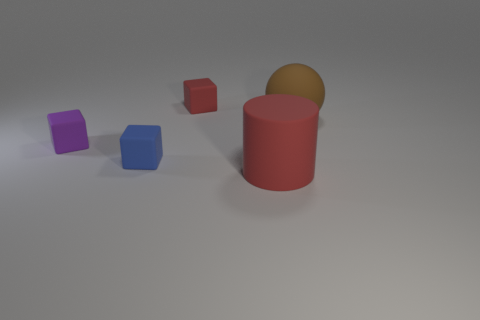Subtract all cylinders. How many objects are left? 4 Add 2 rubber spheres. How many objects exist? 7 Add 2 blue rubber objects. How many blue rubber objects are left? 3 Add 3 tiny purple matte cubes. How many tiny purple matte cubes exist? 4 Subtract 1 red blocks. How many objects are left? 4 Subtract all brown matte cubes. Subtract all big rubber cylinders. How many objects are left? 4 